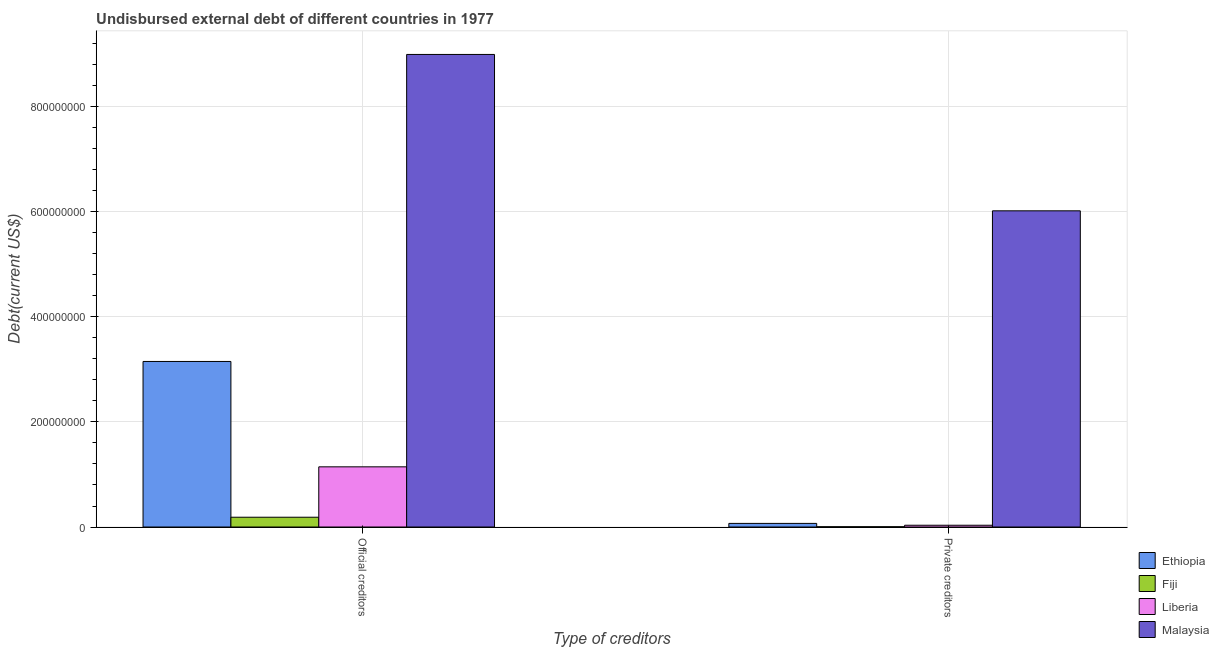How many groups of bars are there?
Give a very brief answer. 2. Are the number of bars on each tick of the X-axis equal?
Your response must be concise. Yes. How many bars are there on the 2nd tick from the left?
Provide a short and direct response. 4. How many bars are there on the 2nd tick from the right?
Provide a short and direct response. 4. What is the label of the 2nd group of bars from the left?
Offer a very short reply. Private creditors. What is the undisbursed external debt of private creditors in Liberia?
Provide a succinct answer. 3.36e+06. Across all countries, what is the maximum undisbursed external debt of private creditors?
Offer a terse response. 6.02e+08. Across all countries, what is the minimum undisbursed external debt of private creditors?
Provide a succinct answer. 5.07e+05. In which country was the undisbursed external debt of private creditors maximum?
Offer a terse response. Malaysia. In which country was the undisbursed external debt of official creditors minimum?
Offer a terse response. Fiji. What is the total undisbursed external debt of official creditors in the graph?
Provide a succinct answer. 1.35e+09. What is the difference between the undisbursed external debt of private creditors in Ethiopia and that in Malaysia?
Your response must be concise. -5.95e+08. What is the difference between the undisbursed external debt of private creditors in Liberia and the undisbursed external debt of official creditors in Fiji?
Your response must be concise. -1.53e+07. What is the average undisbursed external debt of official creditors per country?
Make the answer very short. 3.37e+08. What is the difference between the undisbursed external debt of private creditors and undisbursed external debt of official creditors in Malaysia?
Your response must be concise. -2.98e+08. What is the ratio of the undisbursed external debt of private creditors in Ethiopia to that in Malaysia?
Provide a short and direct response. 0.01. In how many countries, is the undisbursed external debt of private creditors greater than the average undisbursed external debt of private creditors taken over all countries?
Keep it short and to the point. 1. What does the 1st bar from the left in Private creditors represents?
Keep it short and to the point. Ethiopia. What does the 3rd bar from the right in Private creditors represents?
Provide a succinct answer. Fiji. How many bars are there?
Provide a succinct answer. 8. Are all the bars in the graph horizontal?
Make the answer very short. No. How many countries are there in the graph?
Your answer should be compact. 4. What is the difference between two consecutive major ticks on the Y-axis?
Your answer should be compact. 2.00e+08. Where does the legend appear in the graph?
Your answer should be compact. Bottom right. How many legend labels are there?
Your answer should be very brief. 4. How are the legend labels stacked?
Your answer should be very brief. Vertical. What is the title of the graph?
Ensure brevity in your answer.  Undisbursed external debt of different countries in 1977. What is the label or title of the X-axis?
Your answer should be very brief. Type of creditors. What is the label or title of the Y-axis?
Offer a very short reply. Debt(current US$). What is the Debt(current US$) in Ethiopia in Official creditors?
Your response must be concise. 3.15e+08. What is the Debt(current US$) of Fiji in Official creditors?
Offer a terse response. 1.86e+07. What is the Debt(current US$) in Liberia in Official creditors?
Your response must be concise. 1.15e+08. What is the Debt(current US$) in Malaysia in Official creditors?
Your answer should be very brief. 9.00e+08. What is the Debt(current US$) in Ethiopia in Private creditors?
Keep it short and to the point. 6.89e+06. What is the Debt(current US$) of Fiji in Private creditors?
Make the answer very short. 5.07e+05. What is the Debt(current US$) in Liberia in Private creditors?
Keep it short and to the point. 3.36e+06. What is the Debt(current US$) of Malaysia in Private creditors?
Ensure brevity in your answer.  6.02e+08. Across all Type of creditors, what is the maximum Debt(current US$) of Ethiopia?
Ensure brevity in your answer.  3.15e+08. Across all Type of creditors, what is the maximum Debt(current US$) of Fiji?
Make the answer very short. 1.86e+07. Across all Type of creditors, what is the maximum Debt(current US$) in Liberia?
Your answer should be very brief. 1.15e+08. Across all Type of creditors, what is the maximum Debt(current US$) in Malaysia?
Your answer should be compact. 9.00e+08. Across all Type of creditors, what is the minimum Debt(current US$) in Ethiopia?
Give a very brief answer. 6.89e+06. Across all Type of creditors, what is the minimum Debt(current US$) of Fiji?
Your answer should be very brief. 5.07e+05. Across all Type of creditors, what is the minimum Debt(current US$) in Liberia?
Provide a short and direct response. 3.36e+06. Across all Type of creditors, what is the minimum Debt(current US$) in Malaysia?
Provide a short and direct response. 6.02e+08. What is the total Debt(current US$) of Ethiopia in the graph?
Offer a very short reply. 3.22e+08. What is the total Debt(current US$) in Fiji in the graph?
Ensure brevity in your answer.  1.91e+07. What is the total Debt(current US$) in Liberia in the graph?
Your answer should be compact. 1.18e+08. What is the total Debt(current US$) of Malaysia in the graph?
Provide a succinct answer. 1.50e+09. What is the difference between the Debt(current US$) in Ethiopia in Official creditors and that in Private creditors?
Give a very brief answer. 3.08e+08. What is the difference between the Debt(current US$) in Fiji in Official creditors and that in Private creditors?
Keep it short and to the point. 1.81e+07. What is the difference between the Debt(current US$) in Liberia in Official creditors and that in Private creditors?
Provide a short and direct response. 1.11e+08. What is the difference between the Debt(current US$) of Malaysia in Official creditors and that in Private creditors?
Ensure brevity in your answer.  2.98e+08. What is the difference between the Debt(current US$) of Ethiopia in Official creditors and the Debt(current US$) of Fiji in Private creditors?
Ensure brevity in your answer.  3.15e+08. What is the difference between the Debt(current US$) of Ethiopia in Official creditors and the Debt(current US$) of Liberia in Private creditors?
Offer a very short reply. 3.12e+08. What is the difference between the Debt(current US$) of Ethiopia in Official creditors and the Debt(current US$) of Malaysia in Private creditors?
Your answer should be very brief. -2.87e+08. What is the difference between the Debt(current US$) of Fiji in Official creditors and the Debt(current US$) of Liberia in Private creditors?
Offer a very short reply. 1.53e+07. What is the difference between the Debt(current US$) of Fiji in Official creditors and the Debt(current US$) of Malaysia in Private creditors?
Keep it short and to the point. -5.83e+08. What is the difference between the Debt(current US$) in Liberia in Official creditors and the Debt(current US$) in Malaysia in Private creditors?
Ensure brevity in your answer.  -4.87e+08. What is the average Debt(current US$) of Ethiopia per Type of creditors?
Offer a very short reply. 1.61e+08. What is the average Debt(current US$) of Fiji per Type of creditors?
Your response must be concise. 9.57e+06. What is the average Debt(current US$) in Liberia per Type of creditors?
Offer a very short reply. 5.90e+07. What is the average Debt(current US$) of Malaysia per Type of creditors?
Your answer should be compact. 7.51e+08. What is the difference between the Debt(current US$) of Ethiopia and Debt(current US$) of Fiji in Official creditors?
Make the answer very short. 2.97e+08. What is the difference between the Debt(current US$) in Ethiopia and Debt(current US$) in Liberia in Official creditors?
Your answer should be compact. 2.01e+08. What is the difference between the Debt(current US$) of Ethiopia and Debt(current US$) of Malaysia in Official creditors?
Your response must be concise. -5.85e+08. What is the difference between the Debt(current US$) of Fiji and Debt(current US$) of Liberia in Official creditors?
Your answer should be very brief. -9.60e+07. What is the difference between the Debt(current US$) of Fiji and Debt(current US$) of Malaysia in Official creditors?
Provide a short and direct response. -8.81e+08. What is the difference between the Debt(current US$) of Liberia and Debt(current US$) of Malaysia in Official creditors?
Offer a terse response. -7.85e+08. What is the difference between the Debt(current US$) of Ethiopia and Debt(current US$) of Fiji in Private creditors?
Your answer should be very brief. 6.38e+06. What is the difference between the Debt(current US$) in Ethiopia and Debt(current US$) in Liberia in Private creditors?
Offer a very short reply. 3.53e+06. What is the difference between the Debt(current US$) of Ethiopia and Debt(current US$) of Malaysia in Private creditors?
Provide a short and direct response. -5.95e+08. What is the difference between the Debt(current US$) of Fiji and Debt(current US$) of Liberia in Private creditors?
Your response must be concise. -2.85e+06. What is the difference between the Debt(current US$) of Fiji and Debt(current US$) of Malaysia in Private creditors?
Your response must be concise. -6.02e+08. What is the difference between the Debt(current US$) of Liberia and Debt(current US$) of Malaysia in Private creditors?
Provide a succinct answer. -5.99e+08. What is the ratio of the Debt(current US$) of Ethiopia in Official creditors to that in Private creditors?
Keep it short and to the point. 45.78. What is the ratio of the Debt(current US$) in Fiji in Official creditors to that in Private creditors?
Give a very brief answer. 36.74. What is the ratio of the Debt(current US$) in Liberia in Official creditors to that in Private creditors?
Offer a very short reply. 34.11. What is the ratio of the Debt(current US$) of Malaysia in Official creditors to that in Private creditors?
Offer a terse response. 1.49. What is the difference between the highest and the second highest Debt(current US$) in Ethiopia?
Your answer should be very brief. 3.08e+08. What is the difference between the highest and the second highest Debt(current US$) in Fiji?
Your answer should be compact. 1.81e+07. What is the difference between the highest and the second highest Debt(current US$) of Liberia?
Make the answer very short. 1.11e+08. What is the difference between the highest and the second highest Debt(current US$) of Malaysia?
Provide a succinct answer. 2.98e+08. What is the difference between the highest and the lowest Debt(current US$) in Ethiopia?
Keep it short and to the point. 3.08e+08. What is the difference between the highest and the lowest Debt(current US$) of Fiji?
Provide a short and direct response. 1.81e+07. What is the difference between the highest and the lowest Debt(current US$) in Liberia?
Offer a terse response. 1.11e+08. What is the difference between the highest and the lowest Debt(current US$) in Malaysia?
Make the answer very short. 2.98e+08. 